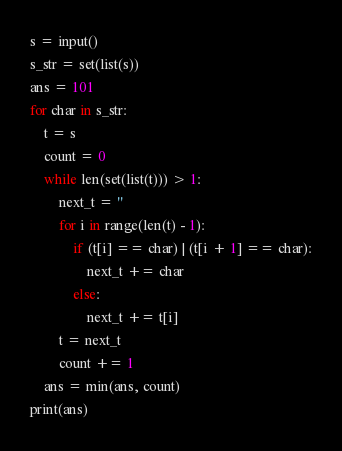Convert code to text. <code><loc_0><loc_0><loc_500><loc_500><_Python_>s = input()
s_str = set(list(s))
ans = 101
for char in s_str:
    t = s
    count = 0
    while len(set(list(t))) > 1:
        next_t = ''        
        for i in range(len(t) - 1):
            if (t[i] == char) | (t[i + 1] == char):
                next_t += char
            else:
                next_t += t[i]
        t = next_t
        count += 1
    ans = min(ans, count)
print(ans)</code> 